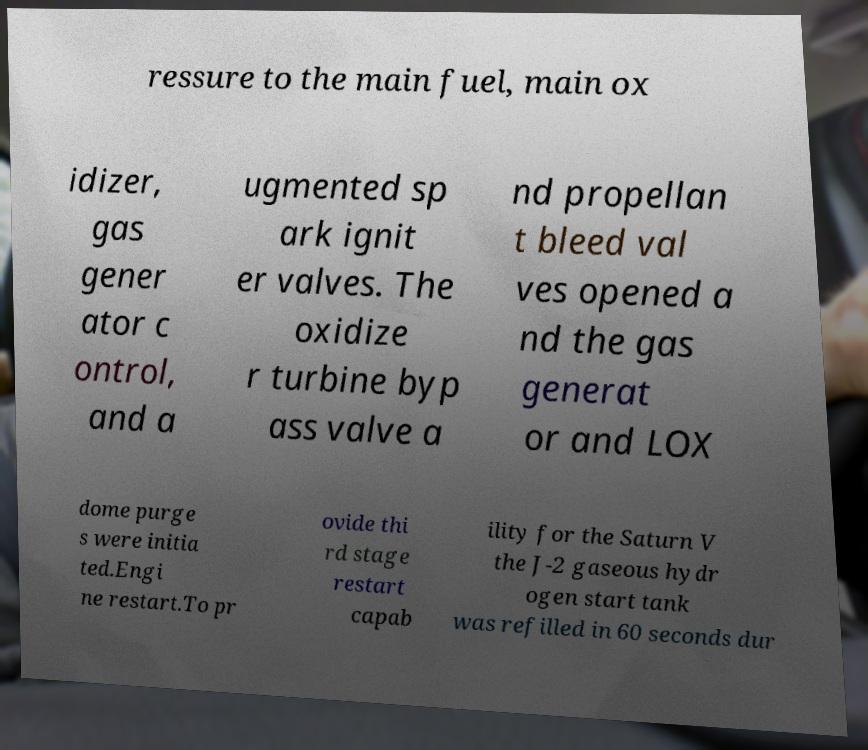Please read and relay the text visible in this image. What does it say? ressure to the main fuel, main ox idizer, gas gener ator c ontrol, and a ugmented sp ark ignit er valves. The oxidize r turbine byp ass valve a nd propellan t bleed val ves opened a nd the gas generat or and LOX dome purge s were initia ted.Engi ne restart.To pr ovide thi rd stage restart capab ility for the Saturn V the J-2 gaseous hydr ogen start tank was refilled in 60 seconds dur 